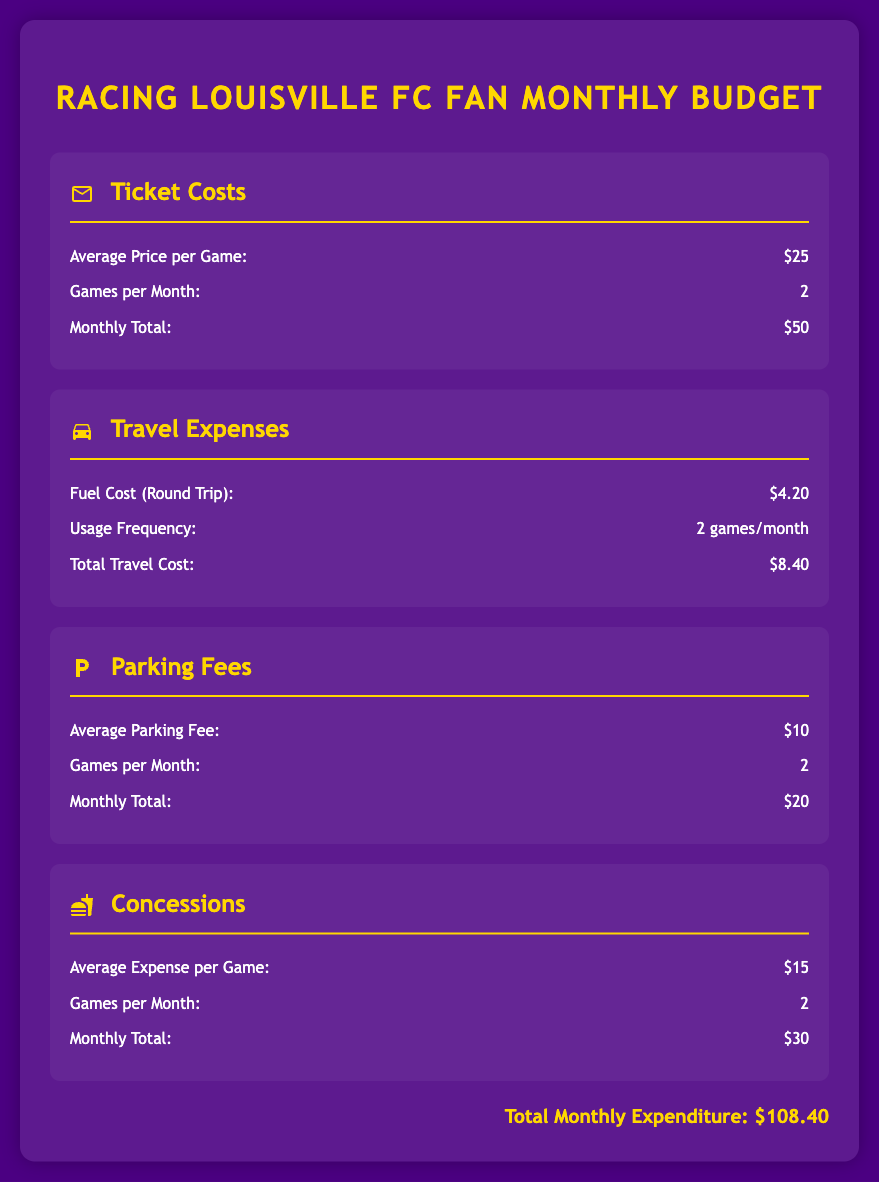What is the average price per game for tickets? The average price per game for tickets is stated in the document under Ticket Costs, which is $25.
Answer: $25 How many games are attended per month? The document specifies that the number of games attended per month is 2, as indicated under Ticket Costs.
Answer: 2 What is the total monthly cost for parking fees? The total monthly cost for parking fees is calculated and stated in the document, which is $20.
Answer: $20 What is the round trip fuel cost for travel? The round trip fuel cost for travel is mentioned in the document as $4.20 under Travel Expenses.
Answer: $4.20 What is the average expense per game for concessions? The average expense per game for concessions is mentioned as $15 under the Concessions section.
Answer: $15 What are the total monthly expenses for attending Racing Louisville FC games? The total monthly expenses are calculated based on all sections of the document and stated as $108.40.
Answer: $108.40 How much is spent on travel expenses per month? The document outlines that the total travel expenses amount to $8.40 per month.
Answer: $8.40 What is the average parking fee per game? The average parking fee per game is detailed in the document, which is $10.
Answer: $10 